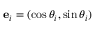Convert formula to latex. <formula><loc_0><loc_0><loc_500><loc_500>e _ { i } = ( \cos \theta _ { i } , \sin \theta _ { i } )</formula> 